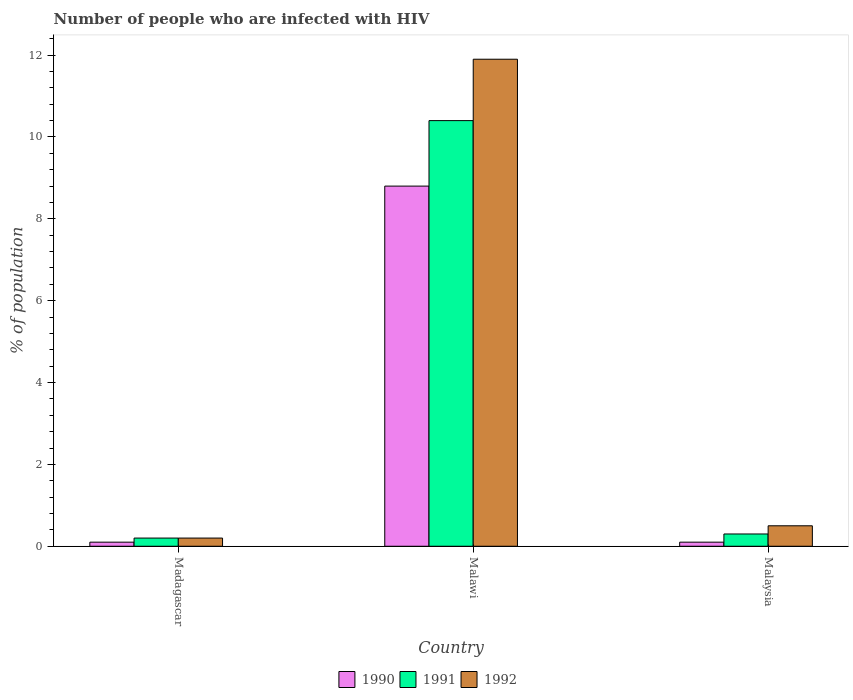How many groups of bars are there?
Keep it short and to the point. 3. How many bars are there on the 2nd tick from the left?
Ensure brevity in your answer.  3. What is the label of the 3rd group of bars from the left?
Your response must be concise. Malaysia. In how many cases, is the number of bars for a given country not equal to the number of legend labels?
Provide a succinct answer. 0. What is the percentage of HIV infected population in in 1991 in Malawi?
Make the answer very short. 10.4. Across all countries, what is the maximum percentage of HIV infected population in in 1991?
Your answer should be compact. 10.4. Across all countries, what is the minimum percentage of HIV infected population in in 1990?
Provide a short and direct response. 0.1. In which country was the percentage of HIV infected population in in 1992 maximum?
Your response must be concise. Malawi. In which country was the percentage of HIV infected population in in 1991 minimum?
Provide a succinct answer. Madagascar. What is the difference between the percentage of HIV infected population in in 1991 in Malawi and that in Malaysia?
Provide a succinct answer. 10.1. What is the difference between the percentage of HIV infected population in in 1991 in Madagascar and the percentage of HIV infected population in in 1992 in Malaysia?
Your answer should be compact. -0.3. What is the average percentage of HIV infected population in in 1991 per country?
Give a very brief answer. 3.63. What is the ratio of the percentage of HIV infected population in in 1992 in Madagascar to that in Malawi?
Your answer should be very brief. 0.02. What is the difference between the highest and the second highest percentage of HIV infected population in in 1990?
Your answer should be very brief. 8.7. What is the difference between the highest and the lowest percentage of HIV infected population in in 1991?
Ensure brevity in your answer.  10.2. Is the sum of the percentage of HIV infected population in in 1990 in Malawi and Malaysia greater than the maximum percentage of HIV infected population in in 1992 across all countries?
Provide a short and direct response. No. What does the 1st bar from the right in Malaysia represents?
Ensure brevity in your answer.  1992. How many bars are there?
Your response must be concise. 9. Are all the bars in the graph horizontal?
Ensure brevity in your answer.  No. What is the difference between two consecutive major ticks on the Y-axis?
Provide a short and direct response. 2. Are the values on the major ticks of Y-axis written in scientific E-notation?
Make the answer very short. No. Does the graph contain grids?
Your response must be concise. No. Where does the legend appear in the graph?
Offer a very short reply. Bottom center. How many legend labels are there?
Keep it short and to the point. 3. How are the legend labels stacked?
Keep it short and to the point. Horizontal. What is the title of the graph?
Provide a succinct answer. Number of people who are infected with HIV. What is the label or title of the Y-axis?
Provide a succinct answer. % of population. What is the % of population of 1991 in Madagascar?
Your answer should be compact. 0.2. What is the % of population of 1990 in Malawi?
Ensure brevity in your answer.  8.8. What is the % of population of 1992 in Malawi?
Ensure brevity in your answer.  11.9. What is the % of population of 1990 in Malaysia?
Ensure brevity in your answer.  0.1. What is the % of population in 1991 in Malaysia?
Provide a short and direct response. 0.3. Across all countries, what is the maximum % of population in 1990?
Make the answer very short. 8.8. Across all countries, what is the maximum % of population of 1992?
Provide a short and direct response. 11.9. Across all countries, what is the minimum % of population in 1991?
Ensure brevity in your answer.  0.2. Across all countries, what is the minimum % of population of 1992?
Your answer should be very brief. 0.2. What is the total % of population of 1991 in the graph?
Your answer should be very brief. 10.9. What is the total % of population of 1992 in the graph?
Offer a very short reply. 12.6. What is the difference between the % of population of 1990 in Madagascar and that in Malawi?
Offer a terse response. -8.7. What is the difference between the % of population of 1992 in Madagascar and that in Malawi?
Ensure brevity in your answer.  -11.7. What is the difference between the % of population of 1990 in Madagascar and that in Malaysia?
Offer a terse response. 0. What is the difference between the % of population of 1992 in Madagascar and that in Malaysia?
Offer a very short reply. -0.3. What is the difference between the % of population of 1990 in Malawi and that in Malaysia?
Your answer should be very brief. 8.7. What is the difference between the % of population in 1992 in Malawi and that in Malaysia?
Offer a very short reply. 11.4. What is the difference between the % of population in 1990 in Madagascar and the % of population in 1991 in Malawi?
Offer a terse response. -10.3. What is the difference between the % of population in 1990 in Madagascar and the % of population in 1991 in Malaysia?
Provide a succinct answer. -0.2. What is the difference between the % of population in 1991 in Madagascar and the % of population in 1992 in Malaysia?
Offer a very short reply. -0.3. What is the average % of population in 1991 per country?
Keep it short and to the point. 3.63. What is the average % of population of 1992 per country?
Provide a succinct answer. 4.2. What is the difference between the % of population in 1990 and % of population in 1991 in Madagascar?
Your response must be concise. -0.1. What is the difference between the % of population of 1990 and % of population of 1992 in Madagascar?
Ensure brevity in your answer.  -0.1. What is the difference between the % of population of 1990 and % of population of 1991 in Malawi?
Provide a short and direct response. -1.6. What is the difference between the % of population of 1991 and % of population of 1992 in Malawi?
Give a very brief answer. -1.5. What is the difference between the % of population in 1990 and % of population in 1991 in Malaysia?
Offer a very short reply. -0.2. What is the ratio of the % of population in 1990 in Madagascar to that in Malawi?
Your answer should be compact. 0.01. What is the ratio of the % of population in 1991 in Madagascar to that in Malawi?
Your response must be concise. 0.02. What is the ratio of the % of population of 1992 in Madagascar to that in Malawi?
Make the answer very short. 0.02. What is the ratio of the % of population in 1992 in Madagascar to that in Malaysia?
Offer a very short reply. 0.4. What is the ratio of the % of population of 1990 in Malawi to that in Malaysia?
Your answer should be very brief. 88. What is the ratio of the % of population in 1991 in Malawi to that in Malaysia?
Provide a short and direct response. 34.67. What is the ratio of the % of population of 1992 in Malawi to that in Malaysia?
Your answer should be very brief. 23.8. What is the difference between the highest and the second highest % of population of 1990?
Your answer should be very brief. 8.7. What is the difference between the highest and the second highest % of population in 1991?
Your answer should be compact. 10.1. What is the difference between the highest and the lowest % of population of 1991?
Provide a succinct answer. 10.2. 